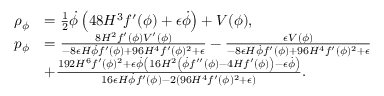<formula> <loc_0><loc_0><loc_500><loc_500>\begin{array} { r l } { \rho _ { \phi } } & { = \frac { 1 } { 2 } \dot { \phi } \left ( 4 8 H ^ { 3 } f ^ { \prime } ( \phi ) + \epsilon \dot { \phi } \right ) + V ( \phi ) , } \\ { p _ { \phi } } & { = \frac { 8 H ^ { 2 } f ^ { \prime } ( \phi ) V ^ { \prime } ( \phi ) } { - 8 \epsilon H \dot { \phi } f ^ { \prime } ( \phi ) + 9 6 H ^ { 4 } f ^ { \prime } ( \phi ) ^ { 2 } + \epsilon } - \frac { \epsilon V ( \phi ) } { - 8 \epsilon H \dot { \phi } f ^ { \prime } ( \phi ) + 9 6 H ^ { 4 } f ^ { \prime } ( \phi ) ^ { 2 } + \epsilon } } \\ & { + \frac { 1 9 2 H ^ { 6 } f ^ { \prime } ( \phi ) ^ { 2 } + \epsilon \dot { \phi } \left ( 1 6 H ^ { 2 } \left ( \dot { \phi } f ^ { \prime \prime } ( \phi ) - 4 H f ^ { \prime } ( \phi ) \right ) - \epsilon \dot { \phi } \right ) } { 1 6 \epsilon H \dot { \phi } f ^ { \prime } ( \phi ) - 2 \left ( 9 6 H ^ { 4 } f ^ { \prime } ( \phi ) ^ { 2 } + \epsilon \right ) } . } \end{array}</formula> 